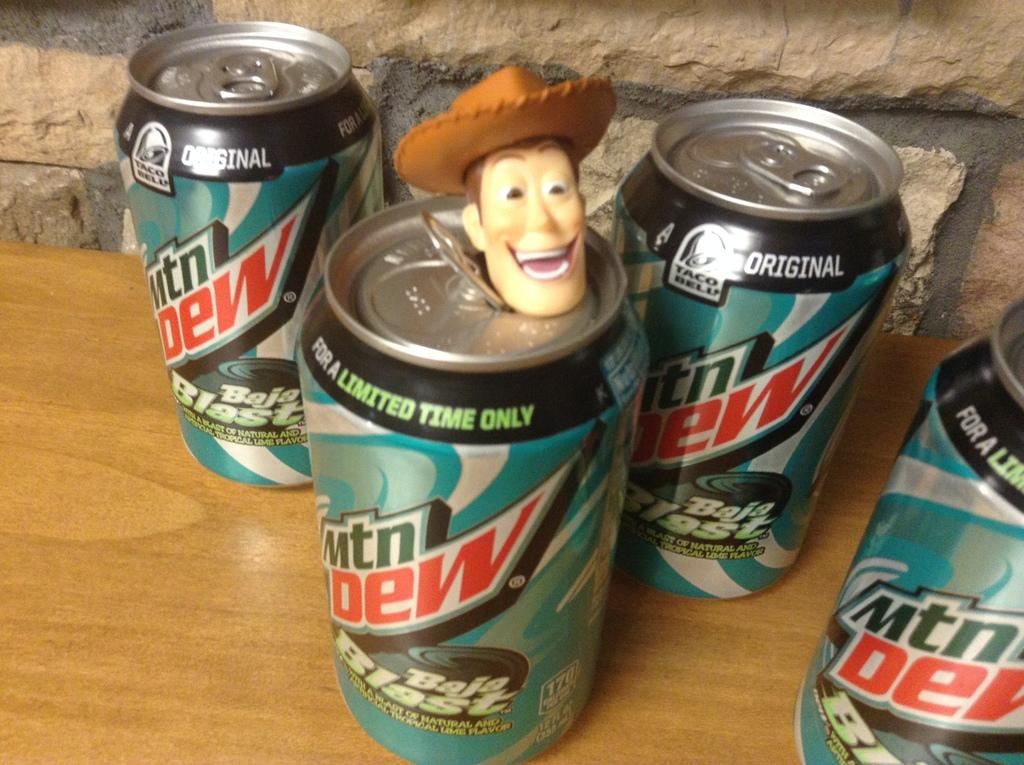<image>
Give a short and clear explanation of the subsequent image. Several cans of Baja Blast indicate that it is a Taco Bell original. 